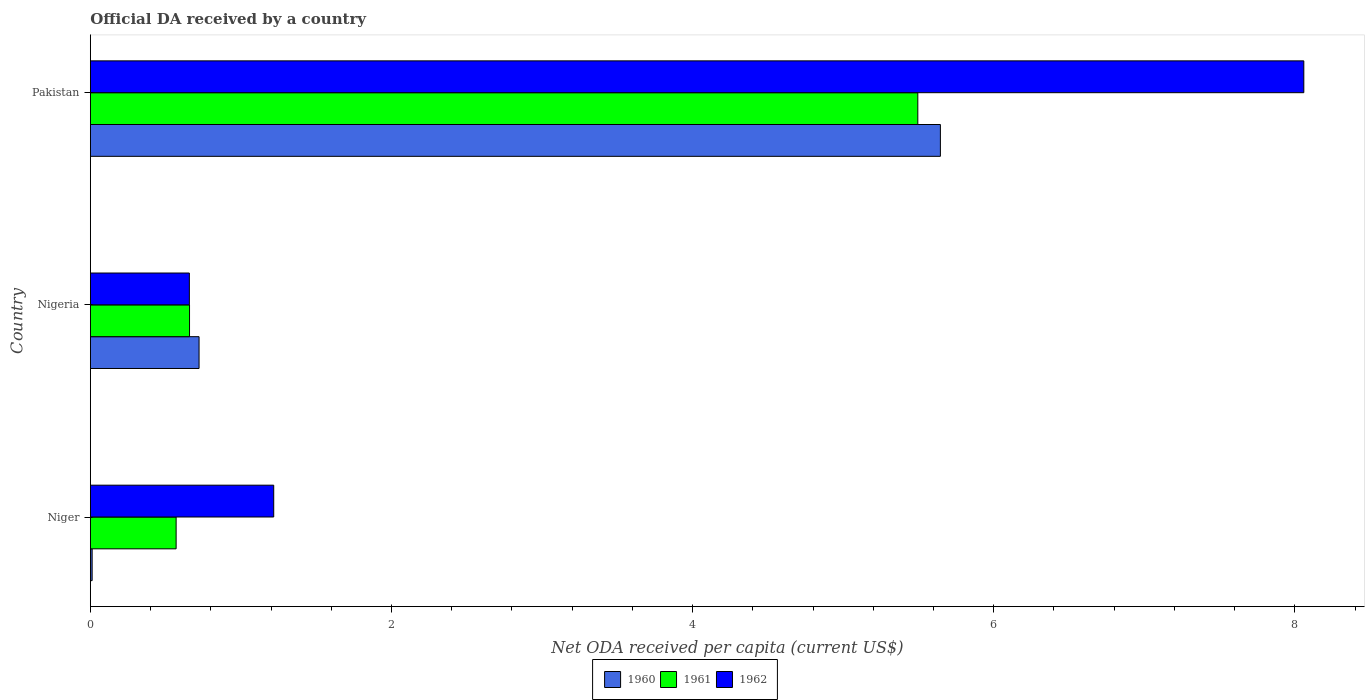Are the number of bars on each tick of the Y-axis equal?
Ensure brevity in your answer.  Yes. How many bars are there on the 2nd tick from the top?
Provide a succinct answer. 3. What is the label of the 2nd group of bars from the top?
Make the answer very short. Nigeria. What is the ODA received in in 1962 in Nigeria?
Make the answer very short. 0.66. Across all countries, what is the maximum ODA received in in 1962?
Offer a terse response. 8.06. Across all countries, what is the minimum ODA received in in 1960?
Make the answer very short. 0.01. In which country was the ODA received in in 1960 maximum?
Your answer should be very brief. Pakistan. In which country was the ODA received in in 1960 minimum?
Offer a very short reply. Niger. What is the total ODA received in in 1962 in the graph?
Your answer should be compact. 9.93. What is the difference between the ODA received in in 1962 in Niger and that in Nigeria?
Ensure brevity in your answer.  0.56. What is the difference between the ODA received in in 1962 in Pakistan and the ODA received in in 1961 in Niger?
Keep it short and to the point. 7.49. What is the average ODA received in in 1961 per country?
Your answer should be compact. 2.24. What is the difference between the ODA received in in 1962 and ODA received in in 1960 in Niger?
Your response must be concise. 1.21. In how many countries, is the ODA received in in 1962 greater than 6 US$?
Keep it short and to the point. 1. What is the ratio of the ODA received in in 1961 in Niger to that in Pakistan?
Provide a succinct answer. 0.1. What is the difference between the highest and the second highest ODA received in in 1961?
Keep it short and to the point. 4.84. What is the difference between the highest and the lowest ODA received in in 1962?
Your answer should be very brief. 7.4. In how many countries, is the ODA received in in 1962 greater than the average ODA received in in 1962 taken over all countries?
Provide a succinct answer. 1. Is the sum of the ODA received in in 1962 in Niger and Nigeria greater than the maximum ODA received in in 1961 across all countries?
Offer a terse response. No. What does the 2nd bar from the top in Nigeria represents?
Offer a very short reply. 1961. Are all the bars in the graph horizontal?
Give a very brief answer. Yes. Are the values on the major ticks of X-axis written in scientific E-notation?
Your answer should be compact. No. Does the graph contain any zero values?
Your answer should be very brief. No. Does the graph contain grids?
Make the answer very short. No. Where does the legend appear in the graph?
Your answer should be very brief. Bottom center. What is the title of the graph?
Your answer should be compact. Official DA received by a country. Does "1990" appear as one of the legend labels in the graph?
Offer a terse response. No. What is the label or title of the X-axis?
Provide a short and direct response. Net ODA received per capita (current US$). What is the Net ODA received per capita (current US$) of 1960 in Niger?
Provide a short and direct response. 0.01. What is the Net ODA received per capita (current US$) in 1961 in Niger?
Your response must be concise. 0.57. What is the Net ODA received per capita (current US$) in 1962 in Niger?
Provide a short and direct response. 1.22. What is the Net ODA received per capita (current US$) in 1960 in Nigeria?
Keep it short and to the point. 0.72. What is the Net ODA received per capita (current US$) in 1961 in Nigeria?
Offer a very short reply. 0.66. What is the Net ODA received per capita (current US$) of 1962 in Nigeria?
Your answer should be compact. 0.66. What is the Net ODA received per capita (current US$) in 1960 in Pakistan?
Give a very brief answer. 5.65. What is the Net ODA received per capita (current US$) of 1961 in Pakistan?
Ensure brevity in your answer.  5.5. What is the Net ODA received per capita (current US$) of 1962 in Pakistan?
Give a very brief answer. 8.06. Across all countries, what is the maximum Net ODA received per capita (current US$) in 1960?
Offer a very short reply. 5.65. Across all countries, what is the maximum Net ODA received per capita (current US$) of 1961?
Give a very brief answer. 5.5. Across all countries, what is the maximum Net ODA received per capita (current US$) of 1962?
Offer a terse response. 8.06. Across all countries, what is the minimum Net ODA received per capita (current US$) of 1960?
Make the answer very short. 0.01. Across all countries, what is the minimum Net ODA received per capita (current US$) in 1961?
Provide a short and direct response. 0.57. Across all countries, what is the minimum Net ODA received per capita (current US$) of 1962?
Your response must be concise. 0.66. What is the total Net ODA received per capita (current US$) of 1960 in the graph?
Keep it short and to the point. 6.38. What is the total Net ODA received per capita (current US$) of 1961 in the graph?
Your answer should be compact. 6.72. What is the total Net ODA received per capita (current US$) in 1962 in the graph?
Your answer should be very brief. 9.93. What is the difference between the Net ODA received per capita (current US$) in 1960 in Niger and that in Nigeria?
Offer a very short reply. -0.71. What is the difference between the Net ODA received per capita (current US$) in 1961 in Niger and that in Nigeria?
Your answer should be very brief. -0.09. What is the difference between the Net ODA received per capita (current US$) of 1962 in Niger and that in Nigeria?
Your answer should be compact. 0.56. What is the difference between the Net ODA received per capita (current US$) in 1960 in Niger and that in Pakistan?
Keep it short and to the point. -5.63. What is the difference between the Net ODA received per capita (current US$) of 1961 in Niger and that in Pakistan?
Make the answer very short. -4.93. What is the difference between the Net ODA received per capita (current US$) of 1962 in Niger and that in Pakistan?
Your answer should be compact. -6.84. What is the difference between the Net ODA received per capita (current US$) in 1960 in Nigeria and that in Pakistan?
Offer a terse response. -4.92. What is the difference between the Net ODA received per capita (current US$) of 1961 in Nigeria and that in Pakistan?
Provide a succinct answer. -4.84. What is the difference between the Net ODA received per capita (current US$) of 1962 in Nigeria and that in Pakistan?
Your response must be concise. -7.4. What is the difference between the Net ODA received per capita (current US$) in 1960 in Niger and the Net ODA received per capita (current US$) in 1961 in Nigeria?
Your response must be concise. -0.65. What is the difference between the Net ODA received per capita (current US$) of 1960 in Niger and the Net ODA received per capita (current US$) of 1962 in Nigeria?
Your answer should be very brief. -0.65. What is the difference between the Net ODA received per capita (current US$) in 1961 in Niger and the Net ODA received per capita (current US$) in 1962 in Nigeria?
Your response must be concise. -0.09. What is the difference between the Net ODA received per capita (current US$) of 1960 in Niger and the Net ODA received per capita (current US$) of 1961 in Pakistan?
Make the answer very short. -5.48. What is the difference between the Net ODA received per capita (current US$) of 1960 in Niger and the Net ODA received per capita (current US$) of 1962 in Pakistan?
Your response must be concise. -8.05. What is the difference between the Net ODA received per capita (current US$) of 1961 in Niger and the Net ODA received per capita (current US$) of 1962 in Pakistan?
Provide a succinct answer. -7.49. What is the difference between the Net ODA received per capita (current US$) of 1960 in Nigeria and the Net ODA received per capita (current US$) of 1961 in Pakistan?
Provide a succinct answer. -4.77. What is the difference between the Net ODA received per capita (current US$) in 1960 in Nigeria and the Net ODA received per capita (current US$) in 1962 in Pakistan?
Offer a terse response. -7.34. What is the difference between the Net ODA received per capita (current US$) in 1961 in Nigeria and the Net ODA received per capita (current US$) in 1962 in Pakistan?
Give a very brief answer. -7.4. What is the average Net ODA received per capita (current US$) of 1960 per country?
Make the answer very short. 2.13. What is the average Net ODA received per capita (current US$) in 1961 per country?
Your answer should be very brief. 2.24. What is the average Net ODA received per capita (current US$) of 1962 per country?
Your answer should be compact. 3.31. What is the difference between the Net ODA received per capita (current US$) in 1960 and Net ODA received per capita (current US$) in 1961 in Niger?
Make the answer very short. -0.56. What is the difference between the Net ODA received per capita (current US$) in 1960 and Net ODA received per capita (current US$) in 1962 in Niger?
Your response must be concise. -1.21. What is the difference between the Net ODA received per capita (current US$) of 1961 and Net ODA received per capita (current US$) of 1962 in Niger?
Offer a terse response. -0.65. What is the difference between the Net ODA received per capita (current US$) of 1960 and Net ODA received per capita (current US$) of 1961 in Nigeria?
Keep it short and to the point. 0.06. What is the difference between the Net ODA received per capita (current US$) of 1960 and Net ODA received per capita (current US$) of 1962 in Nigeria?
Your answer should be very brief. 0.06. What is the difference between the Net ODA received per capita (current US$) of 1961 and Net ODA received per capita (current US$) of 1962 in Nigeria?
Keep it short and to the point. 0. What is the difference between the Net ODA received per capita (current US$) of 1960 and Net ODA received per capita (current US$) of 1962 in Pakistan?
Ensure brevity in your answer.  -2.41. What is the difference between the Net ODA received per capita (current US$) in 1961 and Net ODA received per capita (current US$) in 1962 in Pakistan?
Ensure brevity in your answer.  -2.56. What is the ratio of the Net ODA received per capita (current US$) in 1960 in Niger to that in Nigeria?
Keep it short and to the point. 0.02. What is the ratio of the Net ODA received per capita (current US$) in 1961 in Niger to that in Nigeria?
Make the answer very short. 0.86. What is the ratio of the Net ODA received per capita (current US$) of 1962 in Niger to that in Nigeria?
Offer a very short reply. 1.85. What is the ratio of the Net ODA received per capita (current US$) of 1960 in Niger to that in Pakistan?
Your response must be concise. 0. What is the ratio of the Net ODA received per capita (current US$) in 1961 in Niger to that in Pakistan?
Your answer should be very brief. 0.1. What is the ratio of the Net ODA received per capita (current US$) of 1962 in Niger to that in Pakistan?
Offer a very short reply. 0.15. What is the ratio of the Net ODA received per capita (current US$) in 1960 in Nigeria to that in Pakistan?
Ensure brevity in your answer.  0.13. What is the ratio of the Net ODA received per capita (current US$) of 1961 in Nigeria to that in Pakistan?
Offer a terse response. 0.12. What is the ratio of the Net ODA received per capita (current US$) of 1962 in Nigeria to that in Pakistan?
Your response must be concise. 0.08. What is the difference between the highest and the second highest Net ODA received per capita (current US$) in 1960?
Your response must be concise. 4.92. What is the difference between the highest and the second highest Net ODA received per capita (current US$) of 1961?
Your answer should be compact. 4.84. What is the difference between the highest and the second highest Net ODA received per capita (current US$) in 1962?
Ensure brevity in your answer.  6.84. What is the difference between the highest and the lowest Net ODA received per capita (current US$) of 1960?
Your answer should be compact. 5.63. What is the difference between the highest and the lowest Net ODA received per capita (current US$) of 1961?
Make the answer very short. 4.93. What is the difference between the highest and the lowest Net ODA received per capita (current US$) of 1962?
Keep it short and to the point. 7.4. 